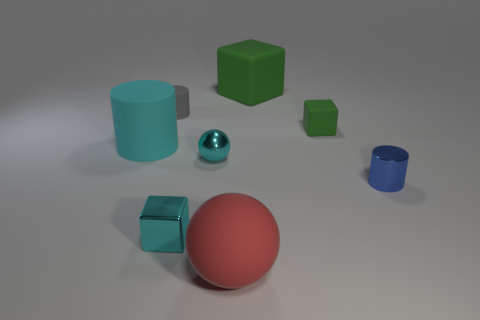Add 1 small rubber cylinders. How many objects exist? 9 Subtract all cylinders. How many objects are left? 5 Add 6 large red spheres. How many large red spheres are left? 7 Add 6 tiny blue cylinders. How many tiny blue cylinders exist? 7 Subtract 0 yellow cylinders. How many objects are left? 8 Subtract all red matte things. Subtract all large red matte objects. How many objects are left? 6 